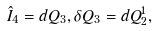<formula> <loc_0><loc_0><loc_500><loc_500>\hat { I } _ { 4 } = d Q _ { 3 } , \delta Q _ { 3 } = d Q _ { 2 } ^ { 1 } ,</formula> 